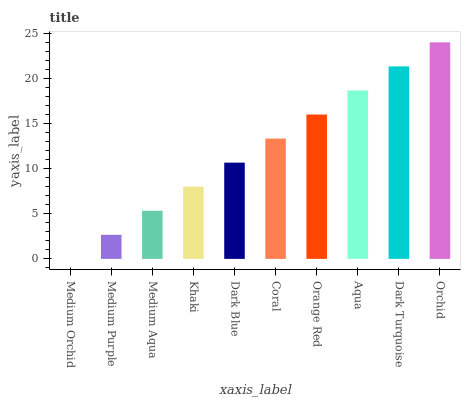Is Medium Orchid the minimum?
Answer yes or no. Yes. Is Orchid the maximum?
Answer yes or no. Yes. Is Medium Purple the minimum?
Answer yes or no. No. Is Medium Purple the maximum?
Answer yes or no. No. Is Medium Purple greater than Medium Orchid?
Answer yes or no. Yes. Is Medium Orchid less than Medium Purple?
Answer yes or no. Yes. Is Medium Orchid greater than Medium Purple?
Answer yes or no. No. Is Medium Purple less than Medium Orchid?
Answer yes or no. No. Is Coral the high median?
Answer yes or no. Yes. Is Dark Blue the low median?
Answer yes or no. Yes. Is Khaki the high median?
Answer yes or no. No. Is Khaki the low median?
Answer yes or no. No. 